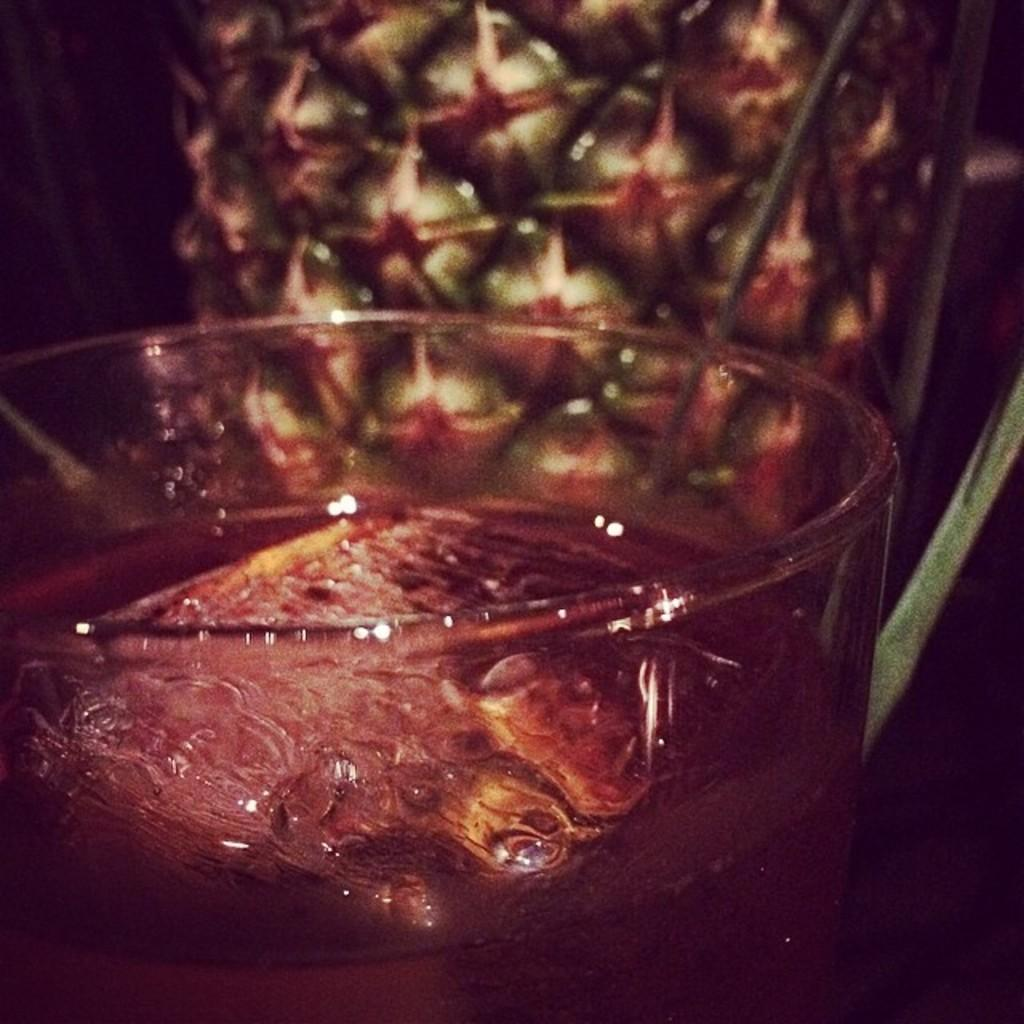What is contained in the glass that is visible in the image? There is a glass with liquid in the image. What other object can be seen in the image? There is an object in the image. Can you describe the object in the background of the image? There is an object in the background of the image. What is located on the right side of the image? There is an object on the right side of the image. What type of trousers can be seen resting near the lake in the image? There is no lake or trousers present in the image. How many people are resting near the lake in the image? There is no lake or people resting in the image. 